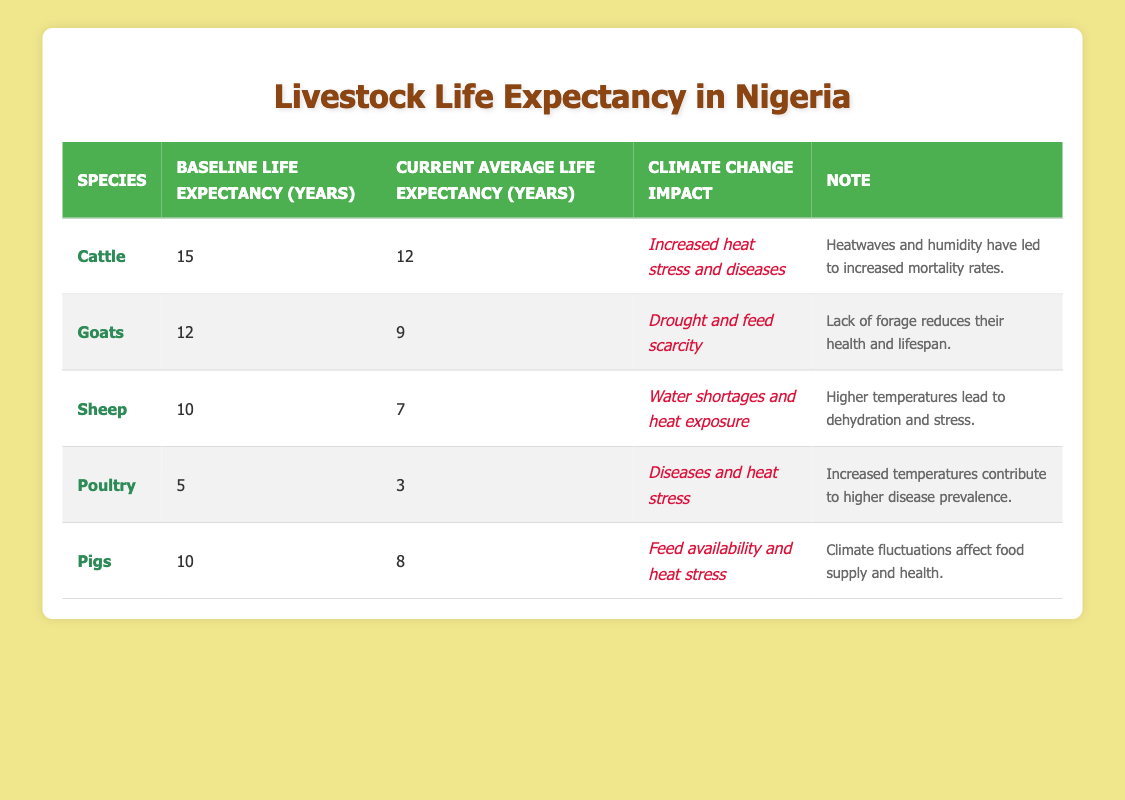What is the baseline life expectancy of sheep? The table directly provides the baseline life expectancy for sheep in the "Baseline Life Expectancy (Years)" column, which is indicated as 10 years.
Answer: 10 years What is the current average life expectancy of pigs? According to the table, the current average life expectancy for pigs is listed in the "Current Average Life Expectancy (Years)" column as 8 years.
Answer: 8 years Does cattle have a higher current average life expectancy than goats? From the table, the current average life expectancy for cattle is 12 years, while for goats it is 9 years. Since 12 is greater than 9, the answer is yes.
Answer: Yes What is the difference between the baseline and current life expectancy for poultry? The baseline life expectancy for poultry is 5 years while the current life expectancy is 3 years. To find the difference: 5 - 3 = 2 years.
Answer: 2 years Which species is most affected by drought and feed scarcity? The table indicates that goats are specifically impacted by drought and feed scarcity. This is stated in the "Climate Change Impact" column for goats.
Answer: Goats What is the average current life expectancy of all livestock species listed in the table? To calculate the average: (12 for cattle + 9 for goats + 7 for sheep + 3 for poultry + 8 for pigs) / 5 = 39 / 5 = 7.8 years.
Answer: 7.8 years Is the climate change impact on sheep related to feed scarcity? The table specifies that sheep are affected by "Water shortages and heat exposure", not by feed scarcity which is associated with goats. Therefore, the answer is no.
Answer: No Which species shows the largest decrease in life expectancy due to climate change? To find which species shows the largest decrease, we subtract the current life expectancy from the baseline life expectancy: Cattle (15 - 12 = 3), Goats (12 - 9 = 3), Sheep (10 - 7 = 3), Poultry (5 - 3 = 2), Pigs (10 - 8 = 2). The maximum decrease is 3 years for cattle, goats, and sheep.
Answer: Cattle, goats, and sheep (3 years decrease for each) How many years of life expectancy do pigs lose compared to their baseline? The baseline life expectancy of pigs is 10 years, and the current average is 8 years. The loss is calculated by subtracting the two values: 10 - 8 = 2 years.
Answer: 2 years 